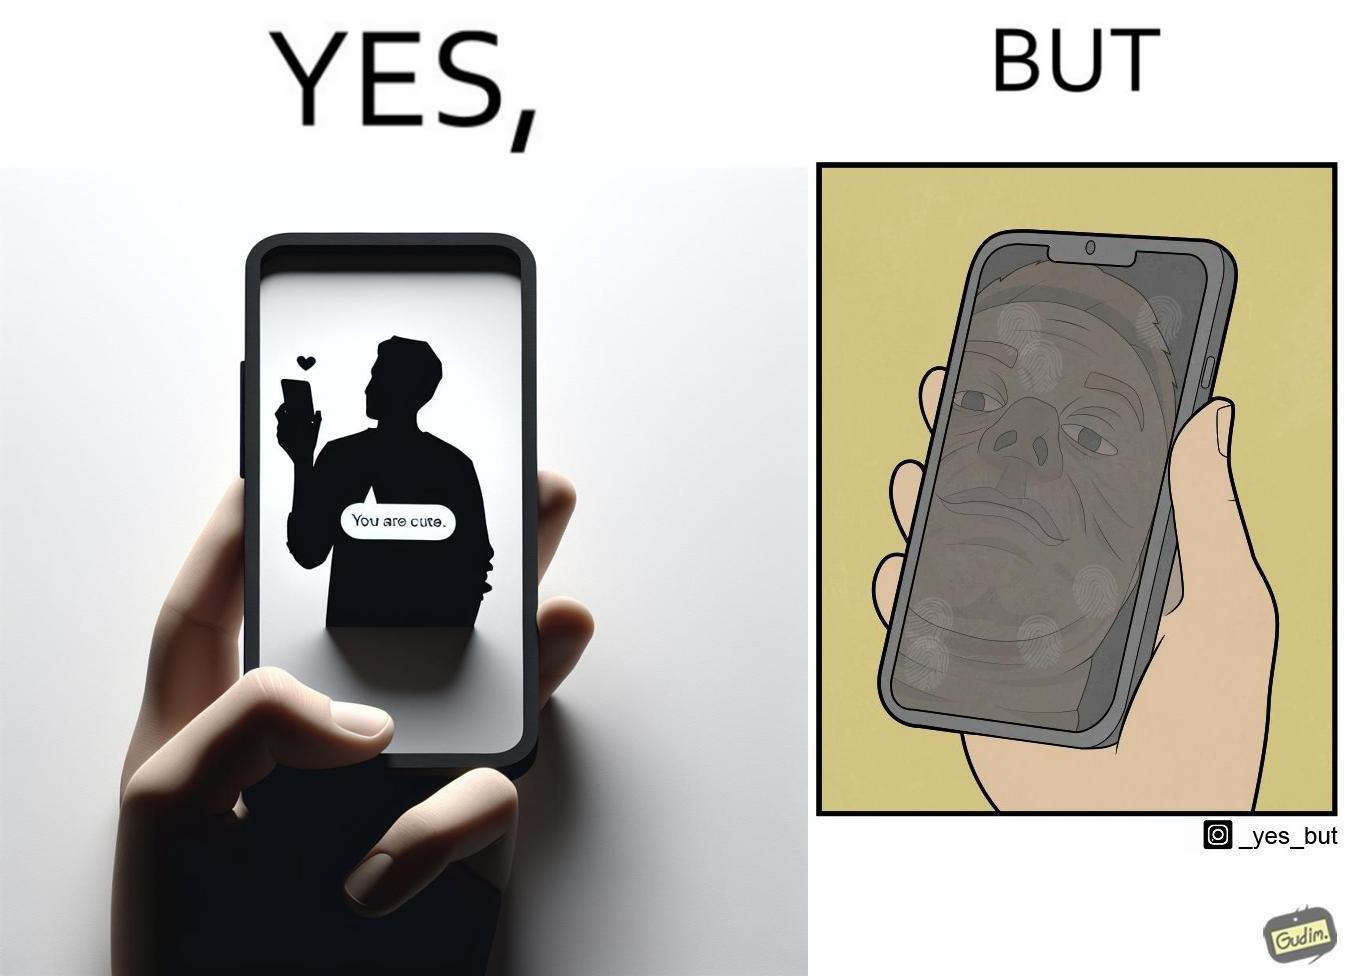Describe the contrast between the left and right parts of this image. In the left part of the image: someone holding a phone and the screen shows a message from someone as "You are cute" In the right part of the image: a person, probably a man, viewing at his face in the phone screen after turned off, the phone screen has touch marks on it 